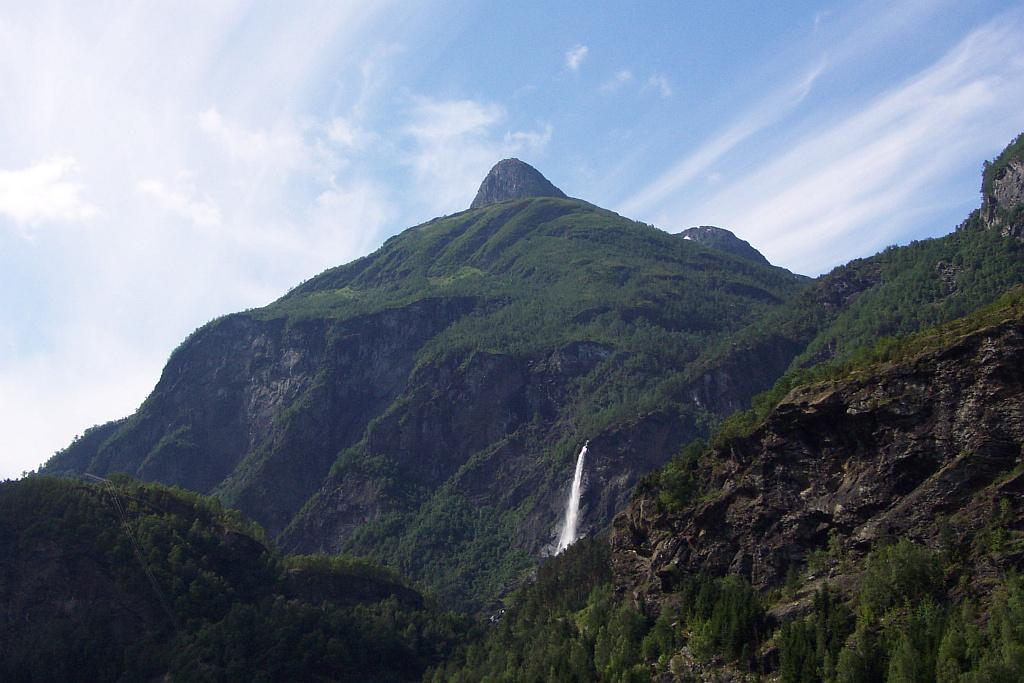What type of natural landscape is depicted in the image? The image features mountains, trees, and a waterfall. Can you describe the vegetation in the image? There are trees and plants visible in the image. Where is the waterfall located in the image? The waterfall is in the center of the image. What is visible at the top of the image? The sky is visible at the top of the image. What can be seen in the sky? Clouds are present in the sky. What type of game is being played on the mountainside in the image? There is no game being played in the image; it features a natural landscape with mountains, trees, and a waterfall. What material is the shoe made of that is visible in the image? There is no shoe present in the image. 